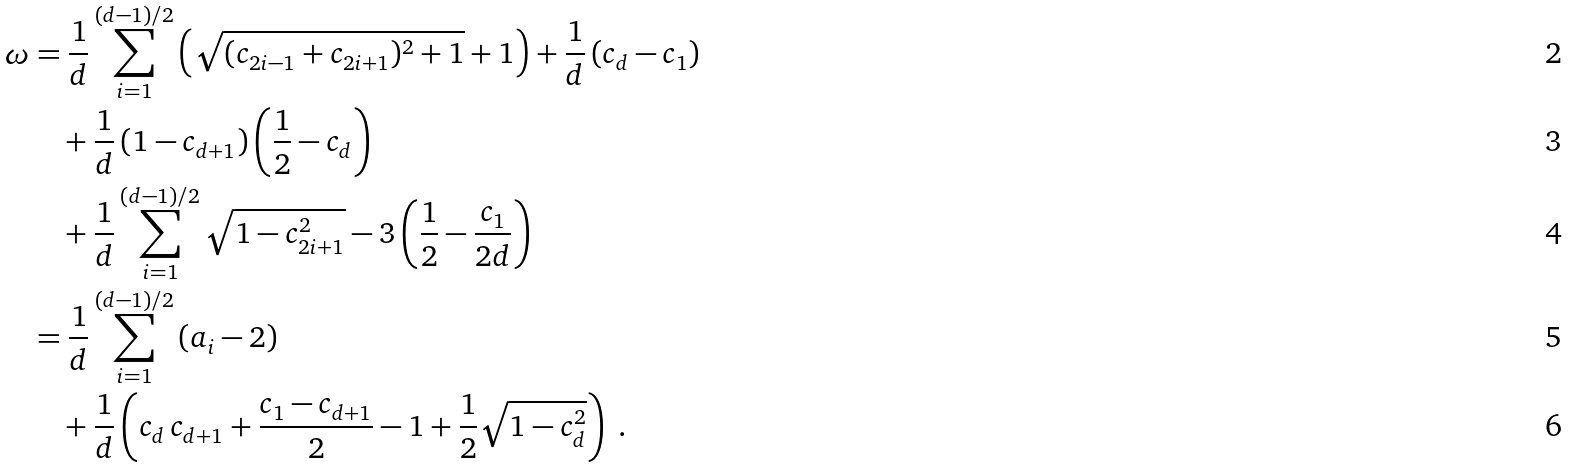Convert formula to latex. <formula><loc_0><loc_0><loc_500><loc_500>\omega & = \frac { 1 } { d } \sum _ { i = 1 } ^ { ( d - 1 ) / 2 } \left ( \sqrt { ( c _ { 2 i - 1 } + c _ { 2 i + 1 } ) ^ { 2 } + 1 } + 1 \right ) + \frac { 1 } { d } \left ( c _ { d } - c _ { 1 } \right ) \\ & \quad + \frac { 1 } { d } \left ( 1 - c _ { d + 1 } \right ) \left ( \frac { 1 } { 2 } - c _ { d } \right ) \\ & \quad + \frac { 1 } { d } \sum _ { i = 1 } ^ { ( d - 1 ) / 2 } \sqrt { 1 - c _ { 2 i + 1 } ^ { 2 } } - 3 \left ( \frac { 1 } { 2 } - \frac { c _ { 1 } } { 2 d } \right ) \\ & = \frac { 1 } { d } \sum _ { i = 1 } ^ { ( d - 1 ) / 2 } \left ( a _ { i } - 2 \right ) \\ & \quad + \frac { 1 } { d } \left ( c _ { d } \, c _ { d + 1 } + \frac { c _ { 1 } - c _ { d + 1 } } { 2 } - 1 + \frac { 1 } { 2 } \sqrt { 1 - c _ { d } ^ { 2 } } \right ) \ .</formula> 